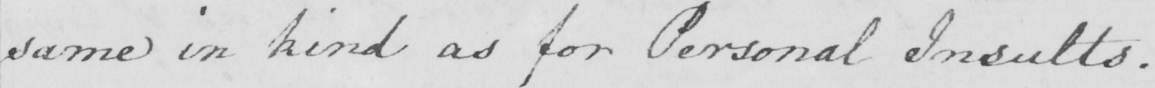Transcribe the text shown in this historical manuscript line. same in kind as for Personal Insults . 